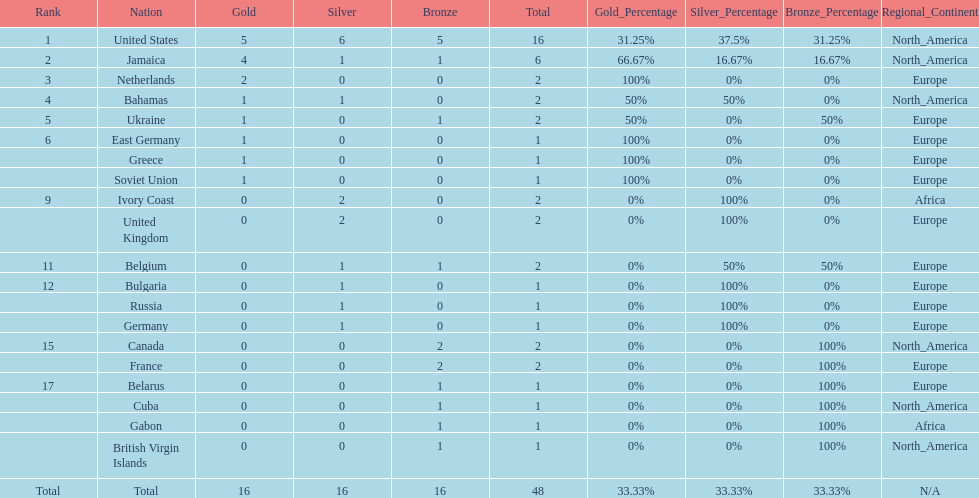What country won the most silver medals? United States. Write the full table. {'header': ['Rank', 'Nation', 'Gold', 'Silver', 'Bronze', 'Total', 'Gold_Percentage', 'Silver_Percentage', 'Bronze_Percentage', 'Regional_Continent'], 'rows': [['1', 'United States', '5', '6', '5', '16', '31.25%', '37.5%', '31.25%', 'North_America'], ['2', 'Jamaica', '4', '1', '1', '6', '66.67%', '16.67%', '16.67%', 'North_America'], ['3', 'Netherlands', '2', '0', '0', '2', '100%', '0%', '0%', 'Europe'], ['4', 'Bahamas', '1', '1', '0', '2', '50%', '50%', '0%', 'North_America'], ['5', 'Ukraine', '1', '0', '1', '2', '50%', '0%', '50%', 'Europe'], ['6', 'East Germany', '1', '0', '0', '1', '100%', '0%', '0%', 'Europe'], ['', 'Greece', '1', '0', '0', '1', '100%', '0%', '0%', 'Europe'], ['', 'Soviet Union', '1', '0', '0', '1', '100%', '0%', '0%', 'Europe'], ['9', 'Ivory Coast', '0', '2', '0', '2', '0%', '100%', '0%', 'Africa'], ['', 'United Kingdom', '0', '2', '0', '2', '0%', '100%', '0%', 'Europe'], ['11', 'Belgium', '0', '1', '1', '2', '0%', '50%', '50%', 'Europe'], ['12', 'Bulgaria', '0', '1', '0', '1', '0%', '100%', '0%', 'Europe'], ['', 'Russia', '0', '1', '0', '1', '0%', '100%', '0%', 'Europe'], ['', 'Germany', '0', '1', '0', '1', '0%', '100%', '0%', 'Europe'], ['15', 'Canada', '0', '0', '2', '2', '0%', '0%', '100%', 'North_America'], ['', 'France', '0', '0', '2', '2', '0%', '0%', '100%', 'Europe'], ['17', 'Belarus', '0', '0', '1', '1', '0%', '0%', '100%', 'Europe'], ['', 'Cuba', '0', '0', '1', '1', '0%', '0%', '100%', 'North_America'], ['', 'Gabon', '0', '0', '1', '1', '0%', '0%', '100%', 'Africa'], ['', 'British Virgin Islands', '0', '0', '1', '1', '0%', '0%', '100%', 'North_America'], ['Total', 'Total', '16', '16', '16', '48', '33.33%', '33.33%', '33.33%', 'N/A']]} 